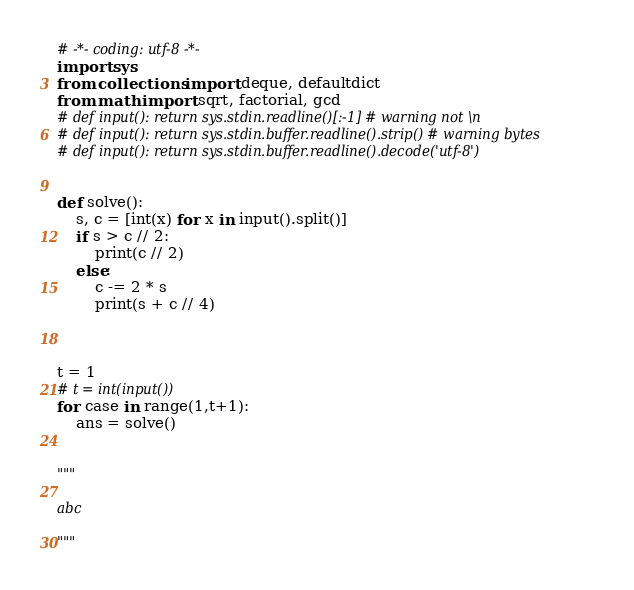<code> <loc_0><loc_0><loc_500><loc_500><_Python_># -*- coding: utf-8 -*-
import sys
from collections import deque, defaultdict
from math import sqrt, factorial, gcd
# def input(): return sys.stdin.readline()[:-1] # warning not \n
# def input(): return sys.stdin.buffer.readline().strip() # warning bytes
# def input(): return sys.stdin.buffer.readline().decode('utf-8')


def solve():
    s, c = [int(x) for x in input().split()]
    if s > c // 2:
        print(c // 2)
    else:
        c -= 2 * s
        print(s + c // 4)
        


t = 1
# t = int(input())
for case in range(1,t+1):
    ans = solve()


"""

abc

"""
</code> 